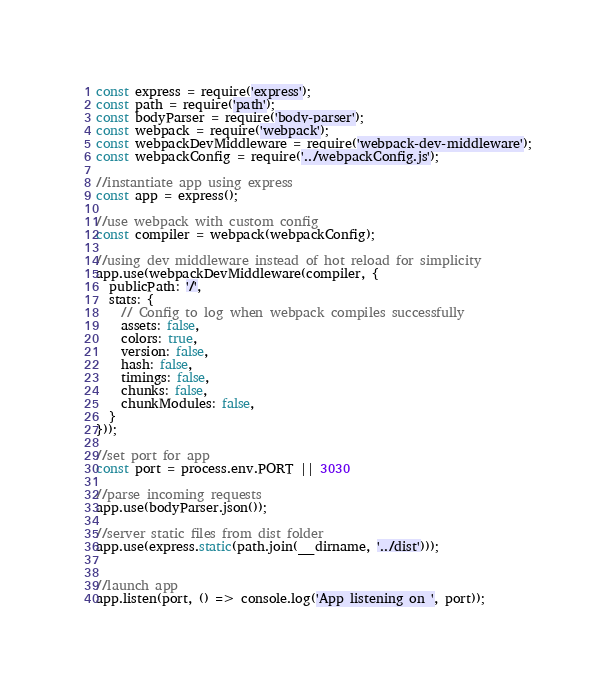<code> <loc_0><loc_0><loc_500><loc_500><_JavaScript_>const express = require('express');
const path = require('path');
const bodyParser = require('body-parser');
const webpack = require('webpack');
const webpackDevMiddleware = require('webpack-dev-middleware');
const webpackConfig = require('../webpackConfig.js');

//instantiate app using express
const app = express();

//use webpack with custom config
const compiler = webpack(webpackConfig);

//using dev middleware instead of hot reload for simplicity
app.use(webpackDevMiddleware(compiler, {
  publicPath: '/',
  stats: {
    // Config to log when webpack compiles successfully
    assets: false,
    colors: true,
    version: false,
    hash: false,
    timings: false,
    chunks: false,
    chunkModules: false,
  }
}));

//set port for app
const port = process.env.PORT || 3030

//parse incoming requests
app.use(bodyParser.json());

//server static files from dist folder
app.use(express.static(path.join(__dirname, '../dist')));


//launch app
app.listen(port, () => console.log('App listening on ', port));
</code> 